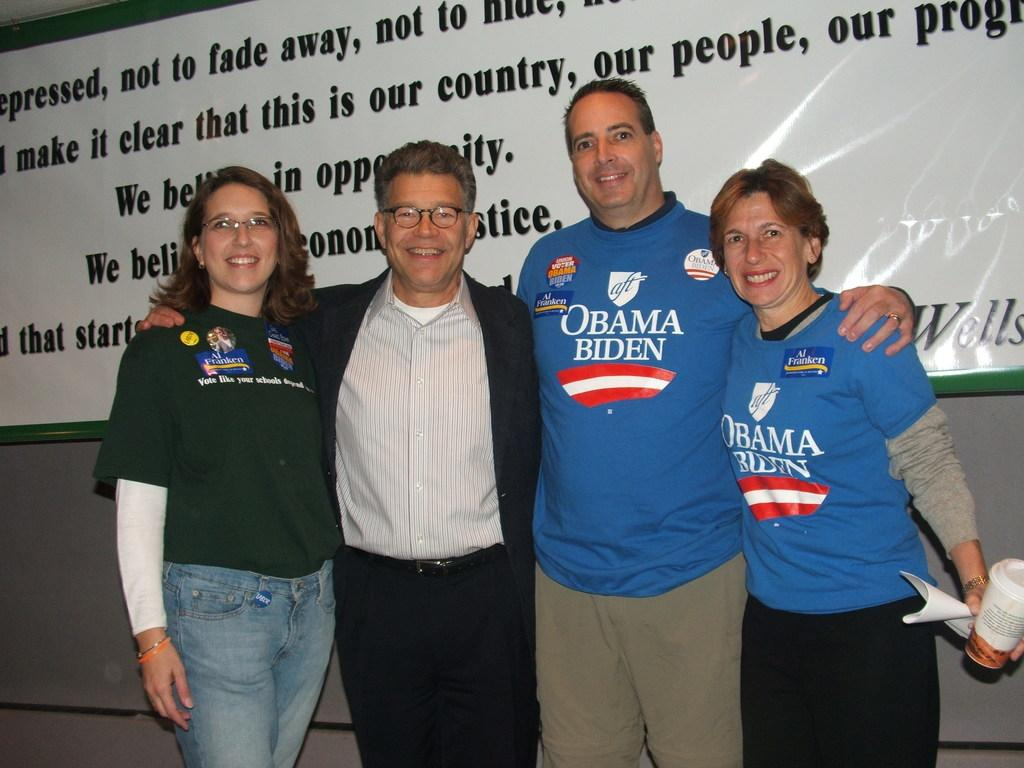<image>
Offer a succinct explanation of the picture presented. A group of four Obama and Biden supporters are posing for a picture. 